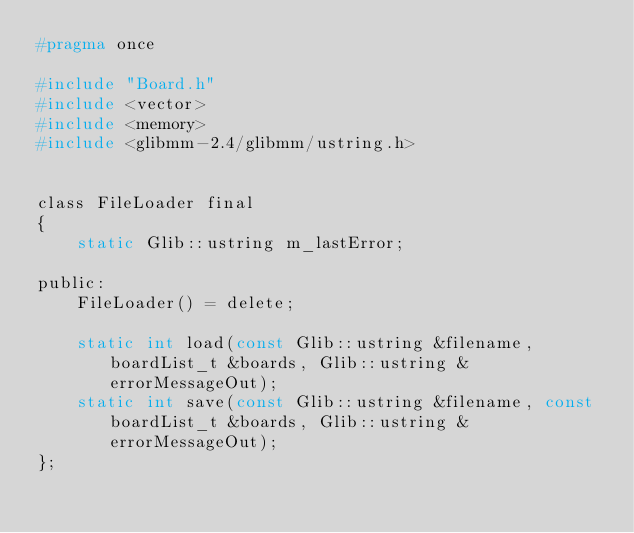Convert code to text. <code><loc_0><loc_0><loc_500><loc_500><_C_>#pragma once

#include "Board.h"
#include <vector>
#include <memory>
#include <glibmm-2.4/glibmm/ustring.h>


class FileLoader final
{
    static Glib::ustring m_lastError;

public:
    FileLoader() = delete;

    static int load(const Glib::ustring &filename, boardList_t &boards, Glib::ustring &errorMessageOut);
    static int save(const Glib::ustring &filename, const boardList_t &boards, Glib::ustring &errorMessageOut);
};

</code> 